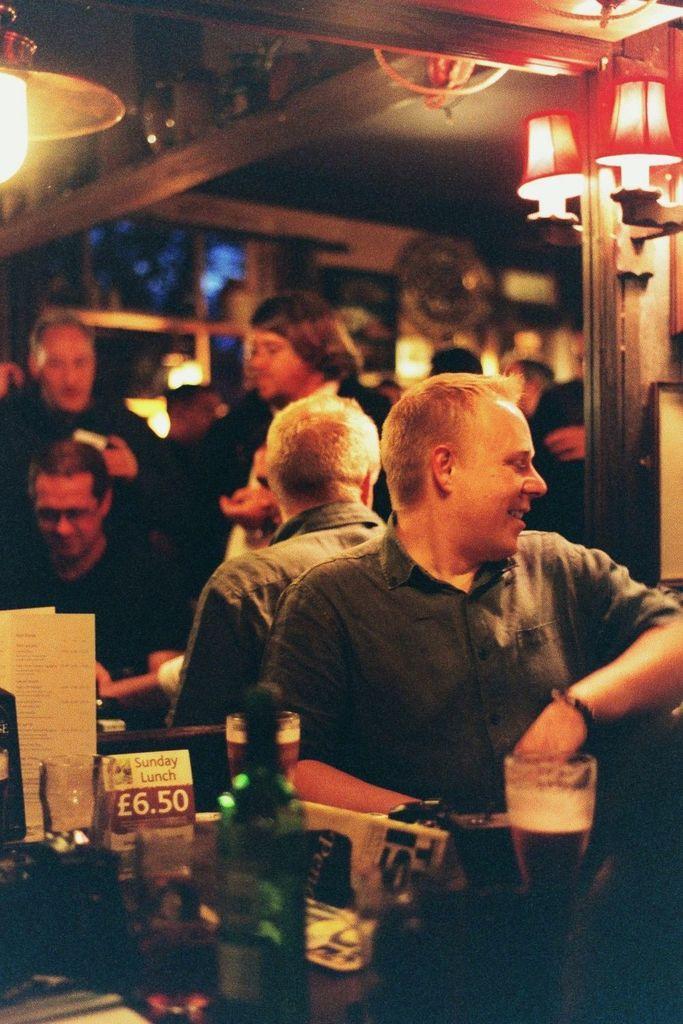Can you describe this image briefly? In the image in the center we can see few people were sitting on the chair around the table and the front person is smiling. On the table,we can see wine glasses,vouchers,wine bottle and few other objects. In the background there is a wall,roof,pole,lights,few people and few other objects. 